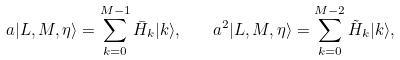<formula> <loc_0><loc_0><loc_500><loc_500>a | L , M , \eta \rangle = \sum _ { k = 0 } ^ { M - 1 } \bar { H } _ { k } | k \rangle , \quad a ^ { 2 } | L , M , \eta \rangle = \sum _ { k = 0 } ^ { M - 2 } \tilde { H } _ { k } | k \rangle ,</formula> 